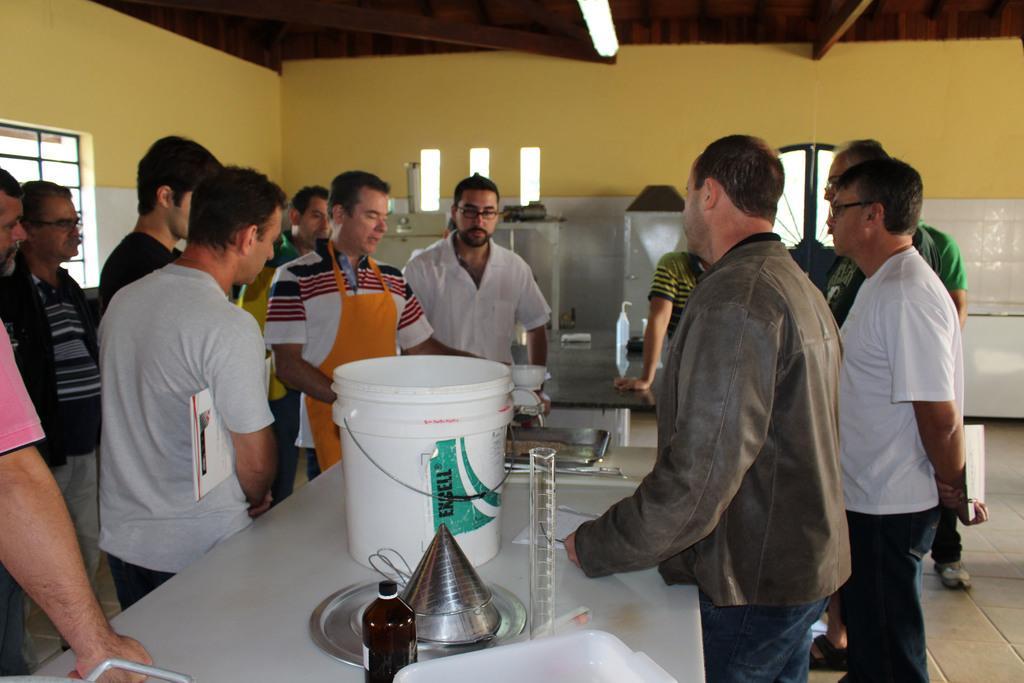Please provide a concise description of this image. This image is clicked inside a room. There is light at the top. There are windows on the left side. There are some persons standing in the middle. There is a table in the middle. On that there are bucket, glass, funnel. 